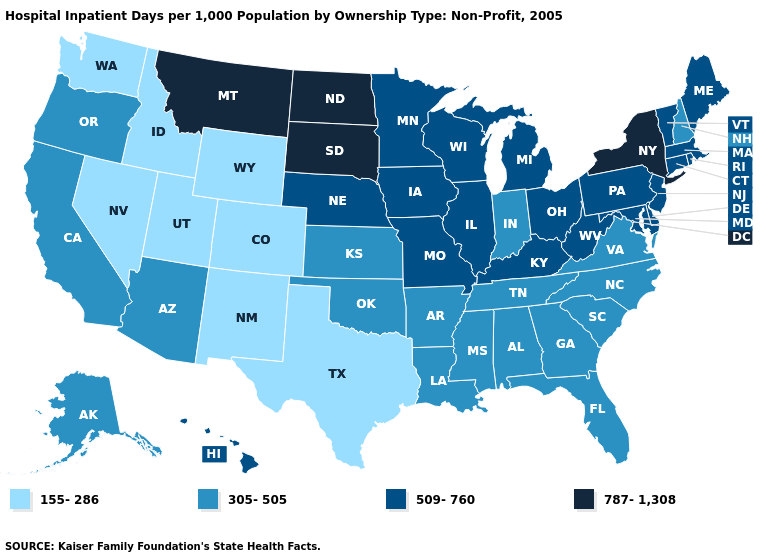Name the states that have a value in the range 509-760?
Write a very short answer. Connecticut, Delaware, Hawaii, Illinois, Iowa, Kentucky, Maine, Maryland, Massachusetts, Michigan, Minnesota, Missouri, Nebraska, New Jersey, Ohio, Pennsylvania, Rhode Island, Vermont, West Virginia, Wisconsin. What is the highest value in states that border Arizona?
Give a very brief answer. 305-505. Name the states that have a value in the range 155-286?
Keep it brief. Colorado, Idaho, Nevada, New Mexico, Texas, Utah, Washington, Wyoming. Does New York have the highest value in the USA?
Be succinct. Yes. Name the states that have a value in the range 305-505?
Quick response, please. Alabama, Alaska, Arizona, Arkansas, California, Florida, Georgia, Indiana, Kansas, Louisiana, Mississippi, New Hampshire, North Carolina, Oklahoma, Oregon, South Carolina, Tennessee, Virginia. Name the states that have a value in the range 305-505?
Concise answer only. Alabama, Alaska, Arizona, Arkansas, California, Florida, Georgia, Indiana, Kansas, Louisiana, Mississippi, New Hampshire, North Carolina, Oklahoma, Oregon, South Carolina, Tennessee, Virginia. Which states have the lowest value in the South?
Answer briefly. Texas. What is the highest value in the USA?
Write a very short answer. 787-1,308. Is the legend a continuous bar?
Short answer required. No. What is the value of Kansas?
Concise answer only. 305-505. Does the map have missing data?
Concise answer only. No. What is the value of Vermont?
Give a very brief answer. 509-760. Does the first symbol in the legend represent the smallest category?
Keep it brief. Yes. Is the legend a continuous bar?
Concise answer only. No. What is the highest value in the USA?
Concise answer only. 787-1,308. 